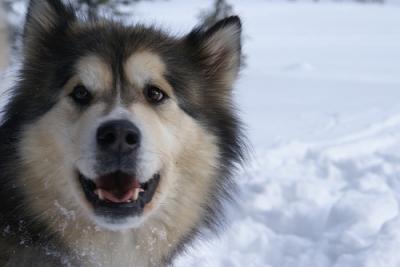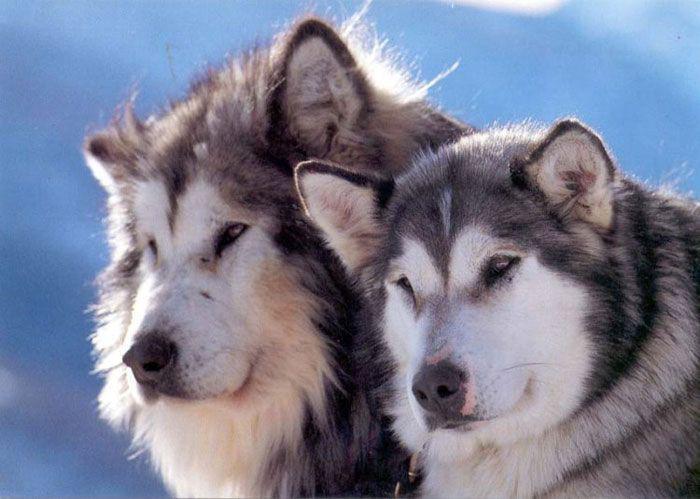The first image is the image on the left, the second image is the image on the right. For the images shown, is this caption "There are exactly two dogs in the snow." true? Answer yes or no. No. 